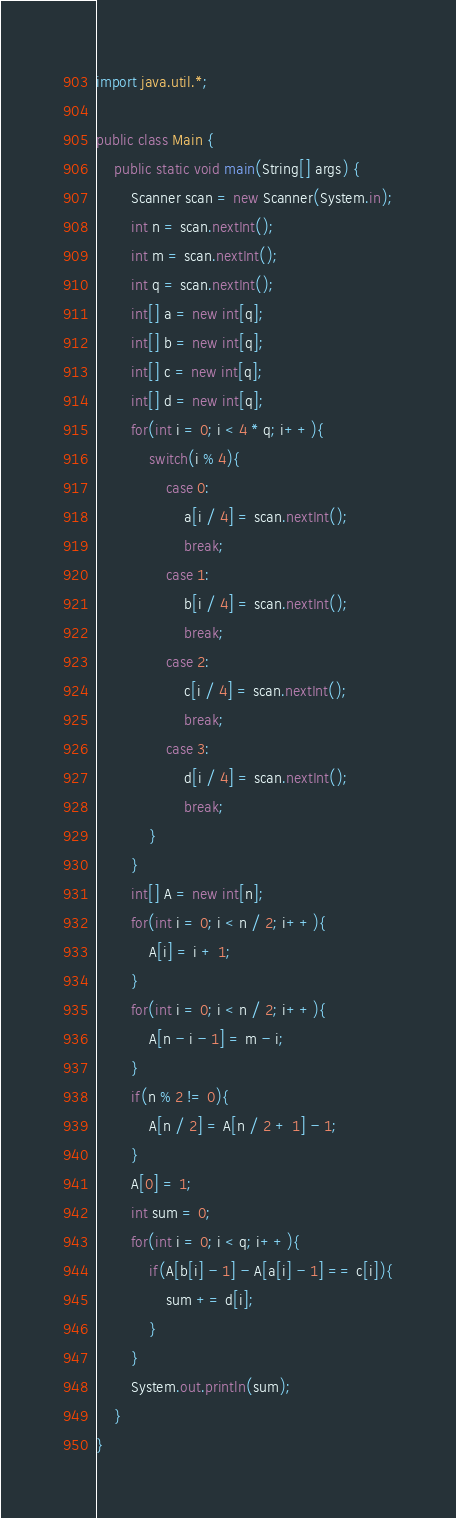Convert code to text. <code><loc_0><loc_0><loc_500><loc_500><_Java_>import java.util.*;

public class Main {
    public static void main(String[] args) {
        Scanner scan = new Scanner(System.in);
        int n = scan.nextInt();
        int m = scan.nextInt();
        int q = scan.nextInt();
        int[] a = new int[q];
        int[] b = new int[q];
        int[] c = new int[q];
        int[] d = new int[q];
        for(int i = 0; i < 4 * q; i++){
            switch(i % 4){
                case 0:
                    a[i / 4] = scan.nextInt();
                    break;
                case 1:
                    b[i / 4] = scan.nextInt();
                    break;
                case 2:
                    c[i / 4] = scan.nextInt();
                    break;
                case 3:
                    d[i / 4] = scan.nextInt();
                    break;
            }
        }
        int[] A = new int[n];
        for(int i = 0; i < n / 2; i++){
            A[i] = i + 1;
        }
        for(int i = 0; i < n / 2; i++){
            A[n - i - 1] = m - i;
        }
        if(n % 2 != 0){
            A[n / 2] = A[n / 2 + 1] - 1;
        }
        A[0] = 1;
        int sum = 0;
        for(int i = 0; i < q; i++){
            if(A[b[i] - 1] - A[a[i] - 1] == c[i]){
                sum += d[i];
            }
        }
        System.out.println(sum);
    }
}</code> 